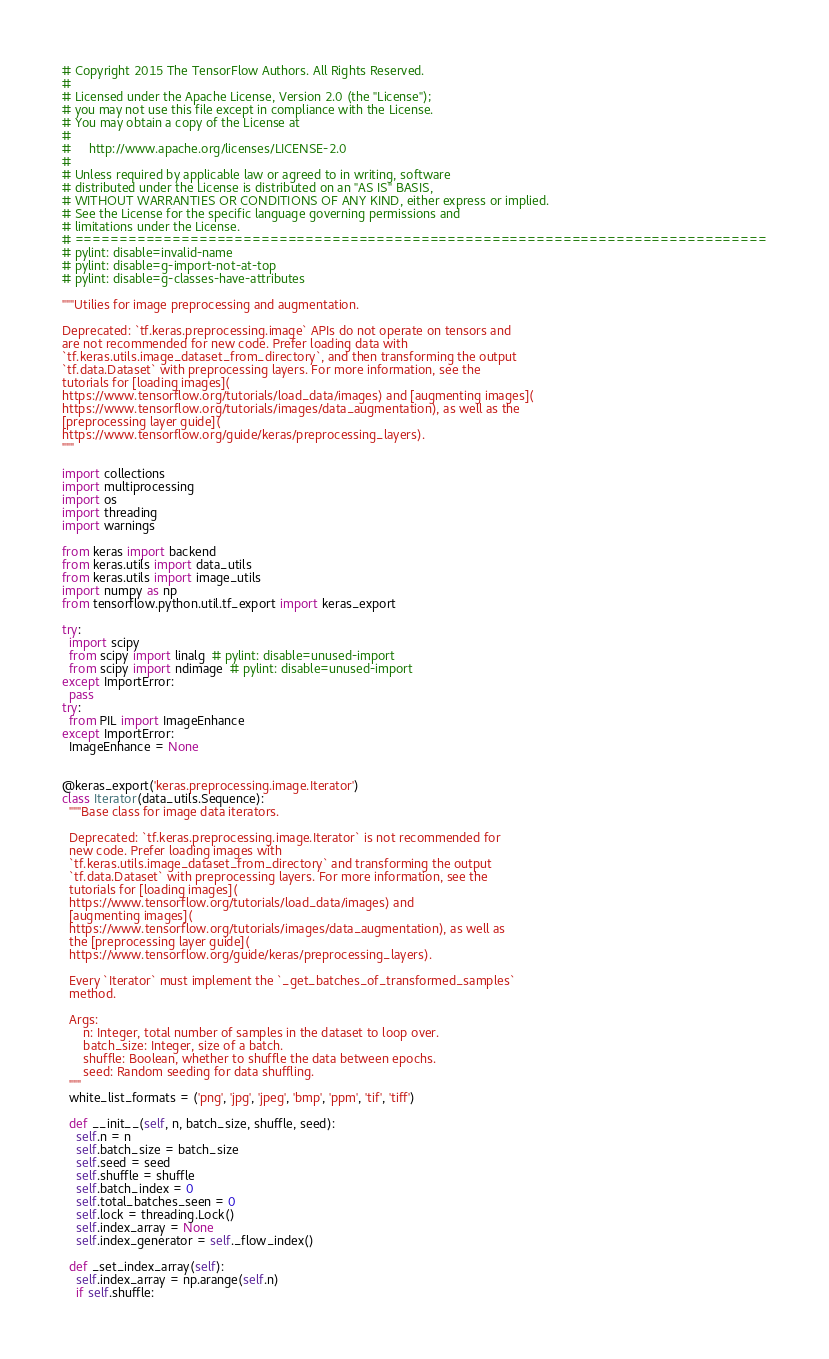Convert code to text. <code><loc_0><loc_0><loc_500><loc_500><_Python_># Copyright 2015 The TensorFlow Authors. All Rights Reserved.
#
# Licensed under the Apache License, Version 2.0 (the "License");
# you may not use this file except in compliance with the License.
# You may obtain a copy of the License at
#
#     http://www.apache.org/licenses/LICENSE-2.0
#
# Unless required by applicable law or agreed to in writing, software
# distributed under the License is distributed on an "AS IS" BASIS,
# WITHOUT WARRANTIES OR CONDITIONS OF ANY KIND, either express or implied.
# See the License for the specific language governing permissions and
# limitations under the License.
# ==============================================================================
# pylint: disable=invalid-name
# pylint: disable=g-import-not-at-top
# pylint: disable=g-classes-have-attributes

"""Utilies for image preprocessing and augmentation.

Deprecated: `tf.keras.preprocessing.image` APIs do not operate on tensors and
are not recommended for new code. Prefer loading data with
`tf.keras.utils.image_dataset_from_directory`, and then transforming the output
`tf.data.Dataset` with preprocessing layers. For more information, see the
tutorials for [loading images](
https://www.tensorflow.org/tutorials/load_data/images) and [augmenting images](
https://www.tensorflow.org/tutorials/images/data_augmentation), as well as the
[preprocessing layer guide](
https://www.tensorflow.org/guide/keras/preprocessing_layers).
"""

import collections
import multiprocessing
import os
import threading
import warnings

from keras import backend
from keras.utils import data_utils
from keras.utils import image_utils
import numpy as np
from tensorflow.python.util.tf_export import keras_export

try:
  import scipy
  from scipy import linalg  # pylint: disable=unused-import
  from scipy import ndimage  # pylint: disable=unused-import
except ImportError:
  pass
try:
  from PIL import ImageEnhance
except ImportError:
  ImageEnhance = None


@keras_export('keras.preprocessing.image.Iterator')
class Iterator(data_utils.Sequence):
  """Base class for image data iterators.

  Deprecated: `tf.keras.preprocessing.image.Iterator` is not recommended for
  new code. Prefer loading images with
  `tf.keras.utils.image_dataset_from_directory` and transforming the output
  `tf.data.Dataset` with preprocessing layers. For more information, see the
  tutorials for [loading images](
  https://www.tensorflow.org/tutorials/load_data/images) and
  [augmenting images](
  https://www.tensorflow.org/tutorials/images/data_augmentation), as well as
  the [preprocessing layer guide](
  https://www.tensorflow.org/guide/keras/preprocessing_layers).

  Every `Iterator` must implement the `_get_batches_of_transformed_samples`
  method.

  Args:
      n: Integer, total number of samples in the dataset to loop over.
      batch_size: Integer, size of a batch.
      shuffle: Boolean, whether to shuffle the data between epochs.
      seed: Random seeding for data shuffling.
  """
  white_list_formats = ('png', 'jpg', 'jpeg', 'bmp', 'ppm', 'tif', 'tiff')

  def __init__(self, n, batch_size, shuffle, seed):
    self.n = n
    self.batch_size = batch_size
    self.seed = seed
    self.shuffle = shuffle
    self.batch_index = 0
    self.total_batches_seen = 0
    self.lock = threading.Lock()
    self.index_array = None
    self.index_generator = self._flow_index()

  def _set_index_array(self):
    self.index_array = np.arange(self.n)
    if self.shuffle:</code> 